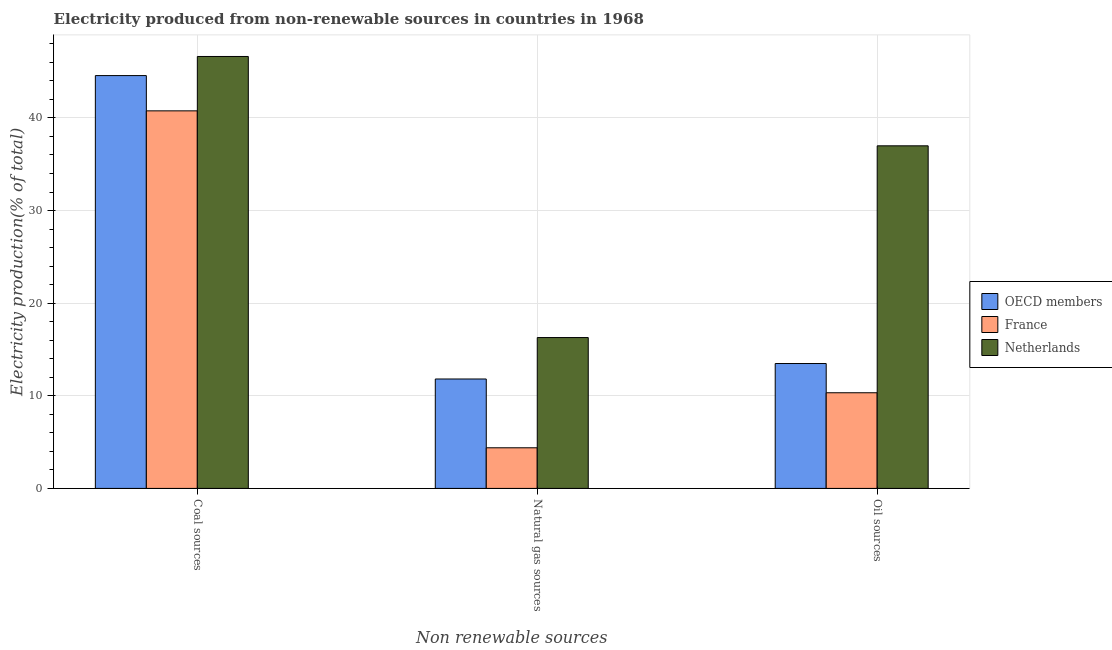How many different coloured bars are there?
Make the answer very short. 3. Are the number of bars per tick equal to the number of legend labels?
Offer a terse response. Yes. How many bars are there on the 2nd tick from the left?
Your answer should be compact. 3. How many bars are there on the 3rd tick from the right?
Your response must be concise. 3. What is the label of the 3rd group of bars from the left?
Your answer should be very brief. Oil sources. What is the percentage of electricity produced by coal in France?
Offer a terse response. 40.77. Across all countries, what is the maximum percentage of electricity produced by oil sources?
Offer a very short reply. 36.99. Across all countries, what is the minimum percentage of electricity produced by natural gas?
Your answer should be compact. 4.39. In which country was the percentage of electricity produced by oil sources maximum?
Provide a short and direct response. Netherlands. In which country was the percentage of electricity produced by natural gas minimum?
Offer a very short reply. France. What is the total percentage of electricity produced by natural gas in the graph?
Ensure brevity in your answer.  32.49. What is the difference between the percentage of electricity produced by natural gas in France and that in Netherlands?
Your answer should be compact. -11.9. What is the difference between the percentage of electricity produced by coal in France and the percentage of electricity produced by natural gas in Netherlands?
Give a very brief answer. 24.48. What is the average percentage of electricity produced by coal per country?
Your answer should be compact. 43.99. What is the difference between the percentage of electricity produced by coal and percentage of electricity produced by oil sources in OECD members?
Give a very brief answer. 31.09. What is the ratio of the percentage of electricity produced by oil sources in France to that in Netherlands?
Provide a succinct answer. 0.28. Is the percentage of electricity produced by oil sources in OECD members less than that in France?
Provide a succinct answer. No. Is the difference between the percentage of electricity produced by oil sources in OECD members and Netherlands greater than the difference between the percentage of electricity produced by coal in OECD members and Netherlands?
Ensure brevity in your answer.  No. What is the difference between the highest and the second highest percentage of electricity produced by natural gas?
Give a very brief answer. 4.47. What is the difference between the highest and the lowest percentage of electricity produced by natural gas?
Provide a succinct answer. 11.9. In how many countries, is the percentage of electricity produced by coal greater than the average percentage of electricity produced by coal taken over all countries?
Keep it short and to the point. 2. Is the sum of the percentage of electricity produced by natural gas in France and OECD members greater than the maximum percentage of electricity produced by oil sources across all countries?
Keep it short and to the point. No. What does the 1st bar from the left in Coal sources represents?
Make the answer very short. OECD members. What does the 2nd bar from the right in Coal sources represents?
Make the answer very short. France. How many bars are there?
Your answer should be very brief. 9. Are all the bars in the graph horizontal?
Offer a very short reply. No. How many countries are there in the graph?
Make the answer very short. 3. What is the difference between two consecutive major ticks on the Y-axis?
Offer a very short reply. 10. Are the values on the major ticks of Y-axis written in scientific E-notation?
Your answer should be very brief. No. Does the graph contain any zero values?
Ensure brevity in your answer.  No. Where does the legend appear in the graph?
Offer a very short reply. Center right. What is the title of the graph?
Provide a short and direct response. Electricity produced from non-renewable sources in countries in 1968. What is the label or title of the X-axis?
Offer a terse response. Non renewable sources. What is the label or title of the Y-axis?
Offer a terse response. Electricity production(% of total). What is the Electricity production(% of total) in OECD members in Coal sources?
Give a very brief answer. 44.57. What is the Electricity production(% of total) in France in Coal sources?
Make the answer very short. 40.77. What is the Electricity production(% of total) in Netherlands in Coal sources?
Your response must be concise. 46.64. What is the Electricity production(% of total) of OECD members in Natural gas sources?
Your answer should be compact. 11.82. What is the Electricity production(% of total) of France in Natural gas sources?
Make the answer very short. 4.39. What is the Electricity production(% of total) in Netherlands in Natural gas sources?
Keep it short and to the point. 16.29. What is the Electricity production(% of total) in OECD members in Oil sources?
Give a very brief answer. 13.48. What is the Electricity production(% of total) of France in Oil sources?
Your response must be concise. 10.33. What is the Electricity production(% of total) in Netherlands in Oil sources?
Provide a succinct answer. 36.99. Across all Non renewable sources, what is the maximum Electricity production(% of total) of OECD members?
Your answer should be compact. 44.57. Across all Non renewable sources, what is the maximum Electricity production(% of total) of France?
Keep it short and to the point. 40.77. Across all Non renewable sources, what is the maximum Electricity production(% of total) in Netherlands?
Your answer should be very brief. 46.64. Across all Non renewable sources, what is the minimum Electricity production(% of total) of OECD members?
Give a very brief answer. 11.82. Across all Non renewable sources, what is the minimum Electricity production(% of total) in France?
Offer a terse response. 4.39. Across all Non renewable sources, what is the minimum Electricity production(% of total) in Netherlands?
Ensure brevity in your answer.  16.29. What is the total Electricity production(% of total) of OECD members in the graph?
Your answer should be compact. 69.87. What is the total Electricity production(% of total) of France in the graph?
Keep it short and to the point. 55.48. What is the total Electricity production(% of total) of Netherlands in the graph?
Your answer should be very brief. 99.92. What is the difference between the Electricity production(% of total) of OECD members in Coal sources and that in Natural gas sources?
Offer a very short reply. 32.76. What is the difference between the Electricity production(% of total) of France in Coal sources and that in Natural gas sources?
Provide a succinct answer. 36.38. What is the difference between the Electricity production(% of total) of Netherlands in Coal sources and that in Natural gas sources?
Give a very brief answer. 30.35. What is the difference between the Electricity production(% of total) in OECD members in Coal sources and that in Oil sources?
Your response must be concise. 31.09. What is the difference between the Electricity production(% of total) of France in Coal sources and that in Oil sources?
Give a very brief answer. 30.44. What is the difference between the Electricity production(% of total) in Netherlands in Coal sources and that in Oil sources?
Your response must be concise. 9.65. What is the difference between the Electricity production(% of total) in OECD members in Natural gas sources and that in Oil sources?
Make the answer very short. -1.67. What is the difference between the Electricity production(% of total) in France in Natural gas sources and that in Oil sources?
Make the answer very short. -5.94. What is the difference between the Electricity production(% of total) of Netherlands in Natural gas sources and that in Oil sources?
Offer a terse response. -20.7. What is the difference between the Electricity production(% of total) of OECD members in Coal sources and the Electricity production(% of total) of France in Natural gas sources?
Make the answer very short. 40.19. What is the difference between the Electricity production(% of total) in OECD members in Coal sources and the Electricity production(% of total) in Netherlands in Natural gas sources?
Give a very brief answer. 28.29. What is the difference between the Electricity production(% of total) in France in Coal sources and the Electricity production(% of total) in Netherlands in Natural gas sources?
Your response must be concise. 24.48. What is the difference between the Electricity production(% of total) in OECD members in Coal sources and the Electricity production(% of total) in France in Oil sources?
Make the answer very short. 34.25. What is the difference between the Electricity production(% of total) in OECD members in Coal sources and the Electricity production(% of total) in Netherlands in Oil sources?
Provide a succinct answer. 7.58. What is the difference between the Electricity production(% of total) of France in Coal sources and the Electricity production(% of total) of Netherlands in Oil sources?
Ensure brevity in your answer.  3.78. What is the difference between the Electricity production(% of total) of OECD members in Natural gas sources and the Electricity production(% of total) of France in Oil sources?
Give a very brief answer. 1.49. What is the difference between the Electricity production(% of total) of OECD members in Natural gas sources and the Electricity production(% of total) of Netherlands in Oil sources?
Keep it short and to the point. -25.18. What is the difference between the Electricity production(% of total) of France in Natural gas sources and the Electricity production(% of total) of Netherlands in Oil sources?
Your answer should be very brief. -32.6. What is the average Electricity production(% of total) in OECD members per Non renewable sources?
Provide a short and direct response. 23.29. What is the average Electricity production(% of total) in France per Non renewable sources?
Offer a very short reply. 18.49. What is the average Electricity production(% of total) of Netherlands per Non renewable sources?
Keep it short and to the point. 33.31. What is the difference between the Electricity production(% of total) in OECD members and Electricity production(% of total) in France in Coal sources?
Offer a very short reply. 3.81. What is the difference between the Electricity production(% of total) in OECD members and Electricity production(% of total) in Netherlands in Coal sources?
Provide a short and direct response. -2.06. What is the difference between the Electricity production(% of total) of France and Electricity production(% of total) of Netherlands in Coal sources?
Keep it short and to the point. -5.87. What is the difference between the Electricity production(% of total) in OECD members and Electricity production(% of total) in France in Natural gas sources?
Give a very brief answer. 7.43. What is the difference between the Electricity production(% of total) of OECD members and Electricity production(% of total) of Netherlands in Natural gas sources?
Offer a terse response. -4.47. What is the difference between the Electricity production(% of total) in France and Electricity production(% of total) in Netherlands in Natural gas sources?
Ensure brevity in your answer.  -11.9. What is the difference between the Electricity production(% of total) of OECD members and Electricity production(% of total) of France in Oil sources?
Give a very brief answer. 3.16. What is the difference between the Electricity production(% of total) in OECD members and Electricity production(% of total) in Netherlands in Oil sources?
Your answer should be very brief. -23.51. What is the difference between the Electricity production(% of total) of France and Electricity production(% of total) of Netherlands in Oil sources?
Keep it short and to the point. -26.66. What is the ratio of the Electricity production(% of total) of OECD members in Coal sources to that in Natural gas sources?
Ensure brevity in your answer.  3.77. What is the ratio of the Electricity production(% of total) in France in Coal sources to that in Natural gas sources?
Ensure brevity in your answer.  9.29. What is the ratio of the Electricity production(% of total) of Netherlands in Coal sources to that in Natural gas sources?
Your answer should be very brief. 2.86. What is the ratio of the Electricity production(% of total) of OECD members in Coal sources to that in Oil sources?
Your response must be concise. 3.31. What is the ratio of the Electricity production(% of total) in France in Coal sources to that in Oil sources?
Provide a short and direct response. 3.95. What is the ratio of the Electricity production(% of total) in Netherlands in Coal sources to that in Oil sources?
Your answer should be compact. 1.26. What is the ratio of the Electricity production(% of total) in OECD members in Natural gas sources to that in Oil sources?
Offer a terse response. 0.88. What is the ratio of the Electricity production(% of total) in France in Natural gas sources to that in Oil sources?
Offer a very short reply. 0.42. What is the ratio of the Electricity production(% of total) in Netherlands in Natural gas sources to that in Oil sources?
Give a very brief answer. 0.44. What is the difference between the highest and the second highest Electricity production(% of total) of OECD members?
Make the answer very short. 31.09. What is the difference between the highest and the second highest Electricity production(% of total) in France?
Provide a succinct answer. 30.44. What is the difference between the highest and the second highest Electricity production(% of total) in Netherlands?
Provide a short and direct response. 9.65. What is the difference between the highest and the lowest Electricity production(% of total) of OECD members?
Your answer should be very brief. 32.76. What is the difference between the highest and the lowest Electricity production(% of total) in France?
Provide a succinct answer. 36.38. What is the difference between the highest and the lowest Electricity production(% of total) in Netherlands?
Your response must be concise. 30.35. 